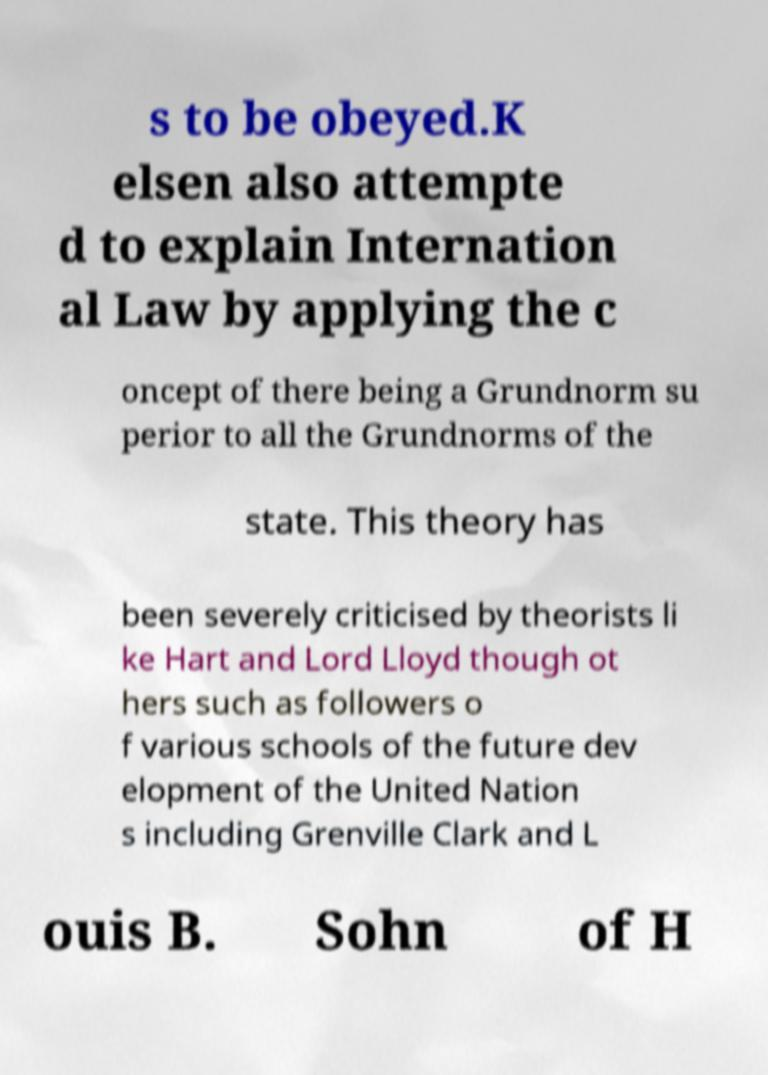Please read and relay the text visible in this image. What does it say? s to be obeyed.K elsen also attempte d to explain Internation al Law by applying the c oncept of there being a Grundnorm su perior to all the Grundnorms of the state. This theory has been severely criticised by theorists li ke Hart and Lord Lloyd though ot hers such as followers o f various schools of the future dev elopment of the United Nation s including Grenville Clark and L ouis B. Sohn of H 